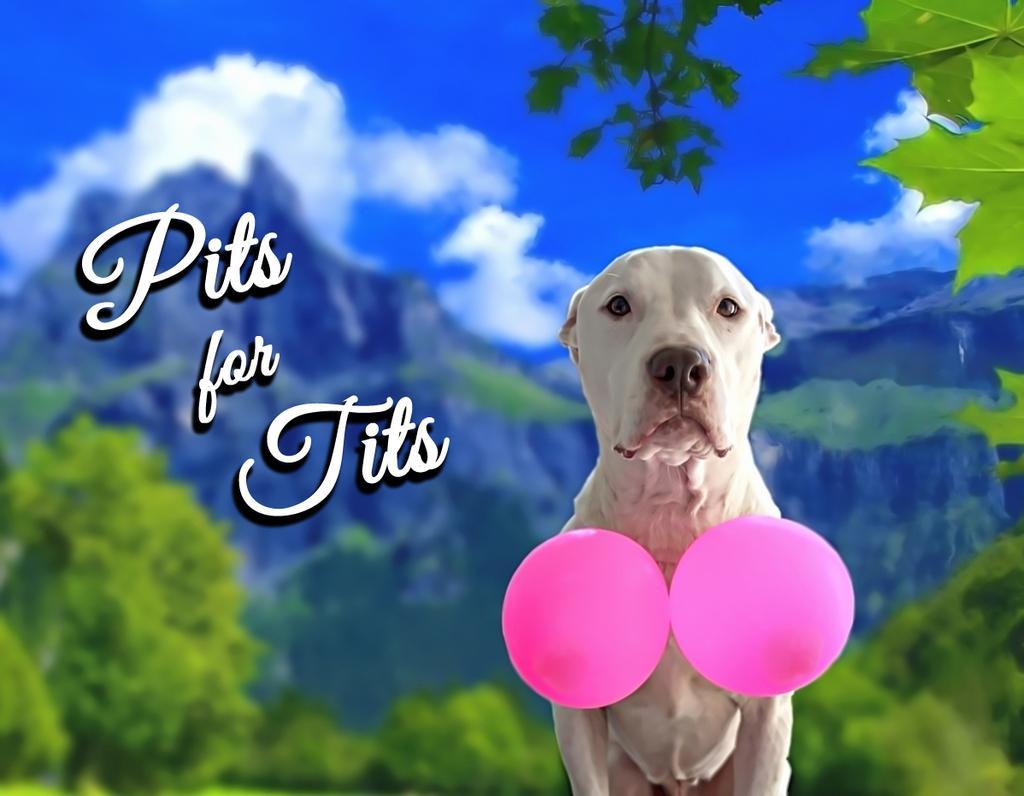Could you give a brief overview of what you see in this image? Here we can see balloons and dog. Something written on this poster. Background it is blur. We can see clouds, mountain and trees. 